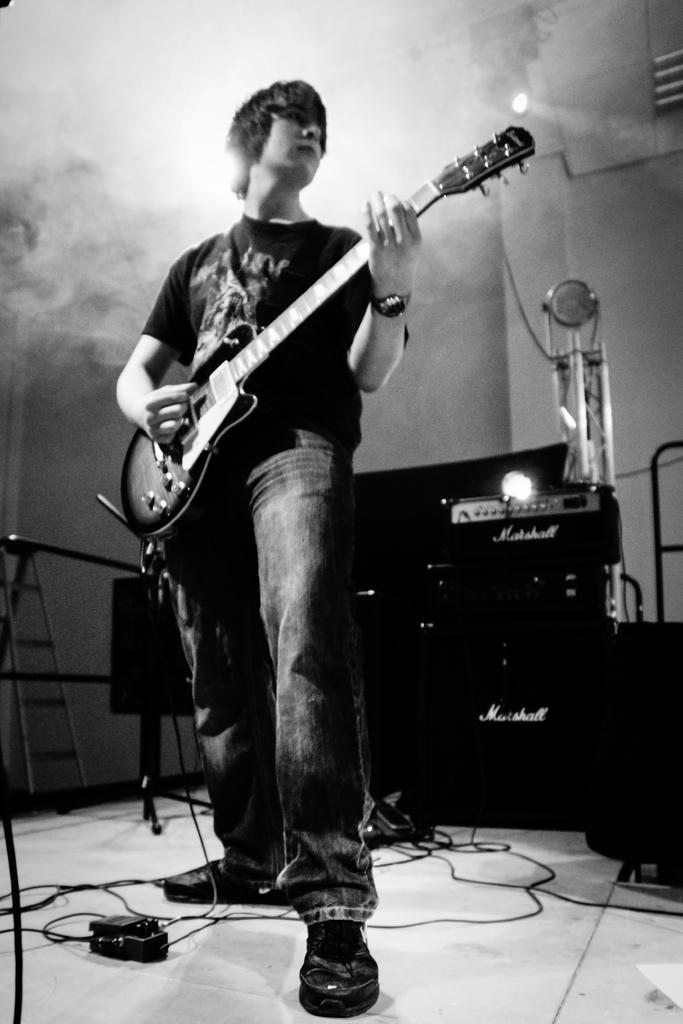What is the man in the image doing? The man is standing and playing a guitar. What equipment is visible in the background? There is a DJ system, a microphone, cables, a ladder, and focus lights in the background. What type of food is the man eating while playing the guitar in the image? There is no food present in the image, and the man is not eating while playing the guitar. 